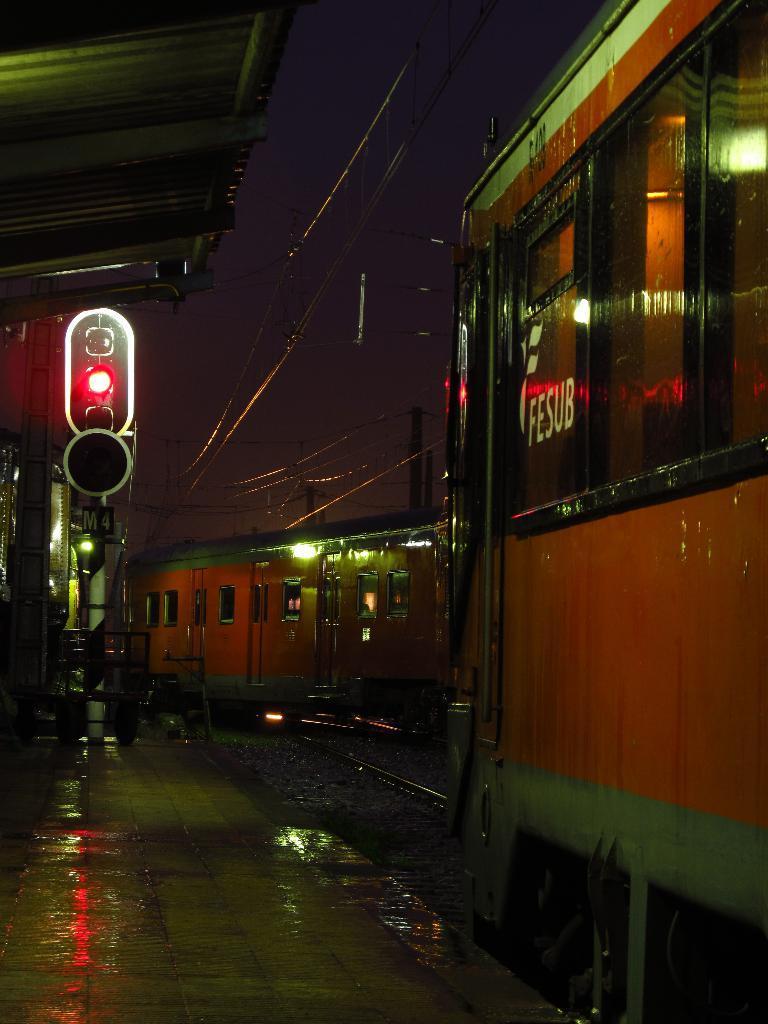How would you summarize this image in a sentence or two? In this image we can see trains on the railway tracks, there are wires and poles on the right side of the image and on the left side of the image there is a traffic light and a shed on the platform and sky in the background. 